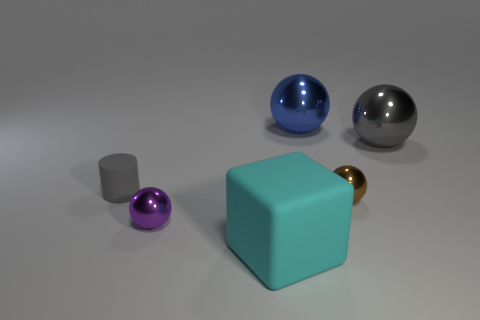Subtract 1 balls. How many balls are left? 3 Add 1 big red shiny cubes. How many objects exist? 7 Subtract all balls. How many objects are left? 2 Subtract all small blue metal objects. Subtract all blue objects. How many objects are left? 5 Add 2 big spheres. How many big spheres are left? 4 Add 2 purple shiny objects. How many purple shiny objects exist? 3 Subtract 1 purple spheres. How many objects are left? 5 